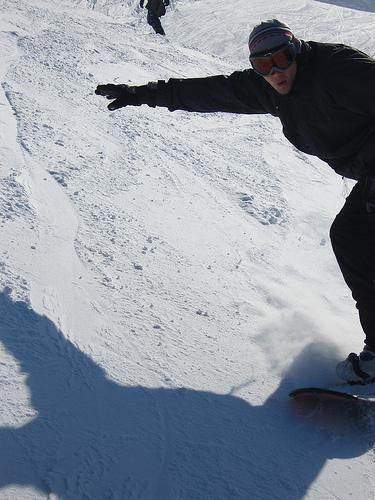Question: who is snowboarding?
Choices:
A. A woman.
B. A boy.
C. A guy.
D. A girl.
Answer with the letter. Answer: C Question: where are the guys?
Choices:
A. On the sidewalk.
B. On the gravel.
C. On the beach.
D. In the snow.
Answer with the letter. Answer: D 